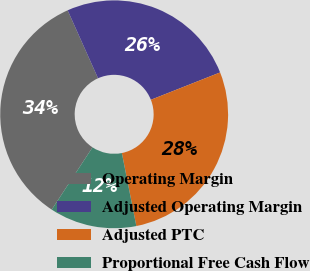Convert chart to OTSL. <chart><loc_0><loc_0><loc_500><loc_500><pie_chart><fcel>Operating Margin<fcel>Adjusted Operating Margin<fcel>Adjusted PTC<fcel>Proportional Free Cash Flow<nl><fcel>34.08%<fcel>25.7%<fcel>27.87%<fcel>12.35%<nl></chart> 